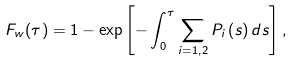Convert formula to latex. <formula><loc_0><loc_0><loc_500><loc_500>F _ { w } ( \tau ) = 1 - \exp \left [ - \int _ { 0 } ^ { \tau } \sum _ { i = 1 , 2 } P _ { i } \left ( s \right ) d s \right ] ,</formula> 